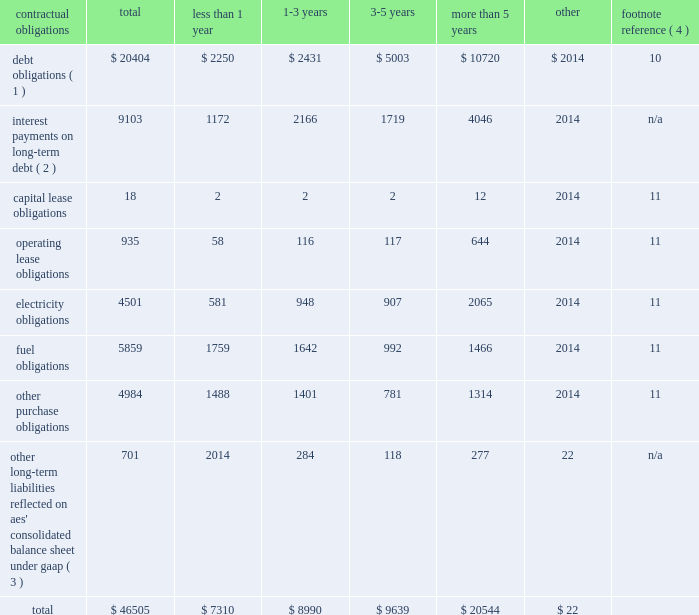2022 triggering our obligation to make payments under any financial guarantee , letter of credit or other credit support we have provided to or on behalf of such subsidiary ; 2022 causing us to record a loss in the event the lender forecloses on the assets ; and 2022 triggering defaults in our outstanding debt at the parent company .
For example , our senior secured credit facility and outstanding debt securities at the parent company include events of default for certain bankruptcy related events involving material subsidiaries .
In addition , our revolving credit agreement at the parent company includes events of default related to payment defaults and accelerations of outstanding debt of material subsidiaries .
Some of our subsidiaries are currently in default with respect to all or a portion of their outstanding indebtedness .
The total non-recourse debt classified as current in the accompanying consolidated balance sheets amounts to $ 2.2 billion .
The portion of current debt related to such defaults was $ 1 billion at december 31 , 2017 , all of which was non-recourse debt related to three subsidiaries 2014 alto maipo , aes puerto rico , and aes ilumina .
See note 10 2014debt in item 8 . 2014financial statements and supplementary data of this form 10-k for additional detail .
None of the subsidiaries that are currently in default are subsidiaries that met the applicable definition of materiality under aes' corporate debt agreements as of december 31 , 2017 in order for such defaults to trigger an event of default or permit acceleration under aes' indebtedness .
However , as a result of additional dispositions of assets , other significant reductions in asset carrying values or other matters in the future that may impact our financial position and results of operations or the financial position of the individual subsidiary , it is possible that one or more of these subsidiaries could fall within the definition of a "material subsidiary" and thereby upon an acceleration trigger an event of default and possible acceleration of the indebtedness under the parent company's outstanding debt securities .
A material subsidiary is defined in the company's senior secured revolving credit facility as any business that contributed 20% ( 20 % ) or more of the parent company's total cash distributions from businesses for the four most recently completed fiscal quarters .
As of december 31 , 2017 , none of the defaults listed above individually or in the aggregate results in or is at risk of triggering a cross-default under the recourse debt of the company .
Contractual obligations and parent company contingent contractual obligations a summary of our contractual obligations , commitments and other liabilities as of december 31 , 2017 is presented below and excludes any businesses classified as discontinued operations or held-for-sale ( in millions ) : contractual obligations total less than 1 year more than 5 years other footnote reference ( 4 ) debt obligations ( 1 ) $ 20404 $ 2250 $ 2431 $ 5003 $ 10720 $ 2014 10 interest payments on long-term debt ( 2 ) 9103 1172 2166 1719 4046 2014 n/a .
_____________________________ ( 1 ) includes recourse and non-recourse debt presented on the consolidated balance sheet .
These amounts exclude capital lease obligations which are included in the capital lease category .
( 2 ) interest payments are estimated based on final maturity dates of debt securities outstanding at december 31 , 2017 and do not reflect anticipated future refinancing , early redemptions or new debt issuances .
Variable rate interest obligations are estimated based on rates as of december 31 , 2017 .
( 3 ) these amounts do not include current liabilities on the consolidated balance sheet except for the current portion of uncertain tax obligations .
Noncurrent uncertain tax obligations are reflected in the "other" column of the table above as the company is not able to reasonably estimate the timing of the future payments .
In addition , these amounts do not include : ( 1 ) regulatory liabilities ( see note 9 2014regulatory assets and liabilities ) , ( 2 ) contingencies ( see note 12 2014contingencies ) , ( 3 ) pension and other postretirement employee benefit liabilities ( see note 13 2014benefit plans ) , ( 4 ) derivatives and incentive compensation ( see note 5 2014derivative instruments and hedging activities ) or ( 5 ) any taxes ( see note 20 2014income taxes ) except for uncertain tax obligations , as the company is not able to reasonably estimate the timing of future payments .
See the indicated notes to the consolidated financial statements included in item 8 of this form 10-k for additional information on the items excluded .
( 4 ) for further information see the note referenced below in item 8 . 2014financial statements and supplementary data of this form 10-k. .
Total capital lease obligations are what percent of operating lease obligations? 
Computations: (18 / 935)
Answer: 0.01925. 